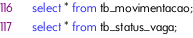<code> <loc_0><loc_0><loc_500><loc_500><_SQL_>select * from tb_movimentacao;
select * from tb_status_vaga;






</code> 